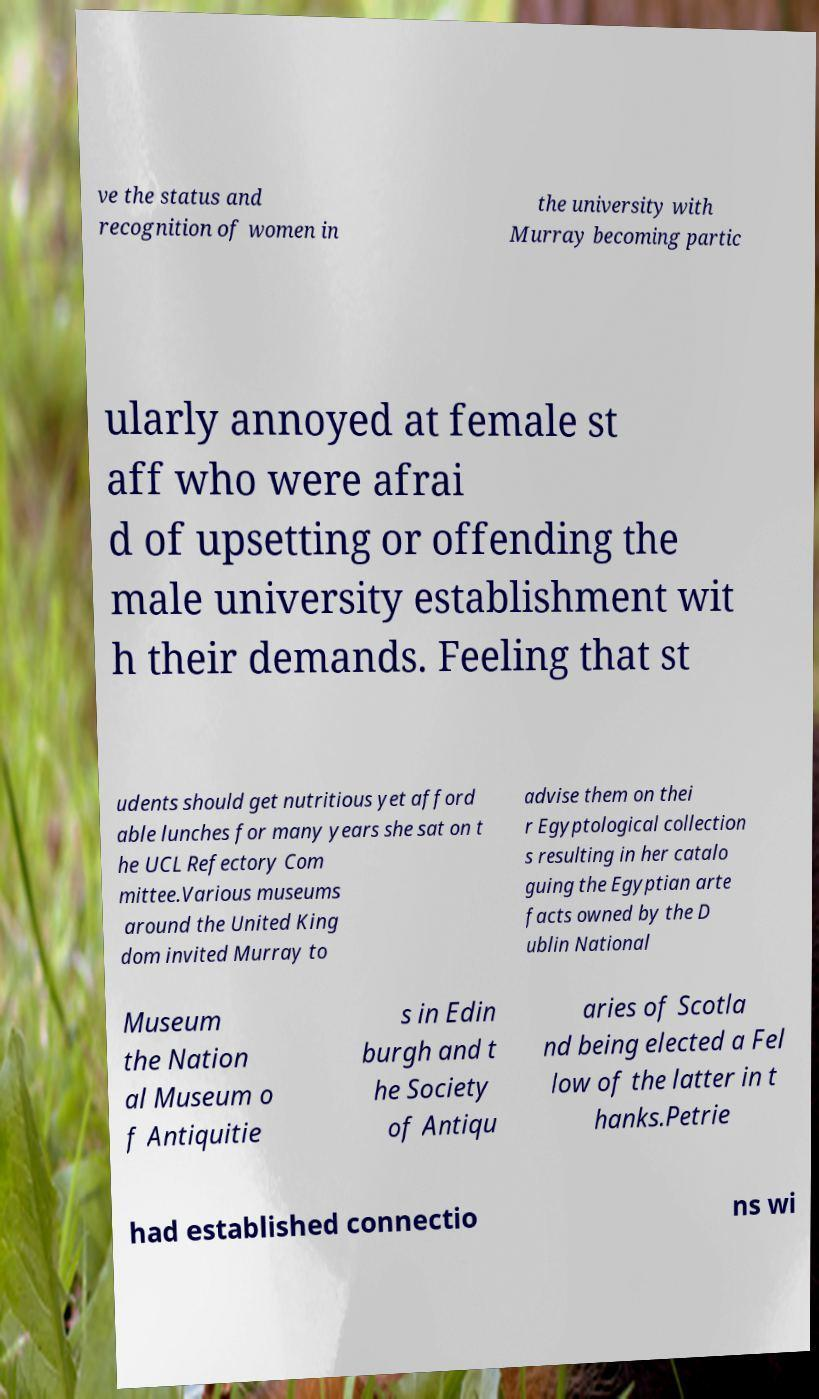What messages or text are displayed in this image? I need them in a readable, typed format. ve the status and recognition of women in the university with Murray becoming partic ularly annoyed at female st aff who were afrai d of upsetting or offending the male university establishment wit h their demands. Feeling that st udents should get nutritious yet afford able lunches for many years she sat on t he UCL Refectory Com mittee.Various museums around the United King dom invited Murray to advise them on thei r Egyptological collection s resulting in her catalo guing the Egyptian arte facts owned by the D ublin National Museum the Nation al Museum o f Antiquitie s in Edin burgh and t he Society of Antiqu aries of Scotla nd being elected a Fel low of the latter in t hanks.Petrie had established connectio ns wi 